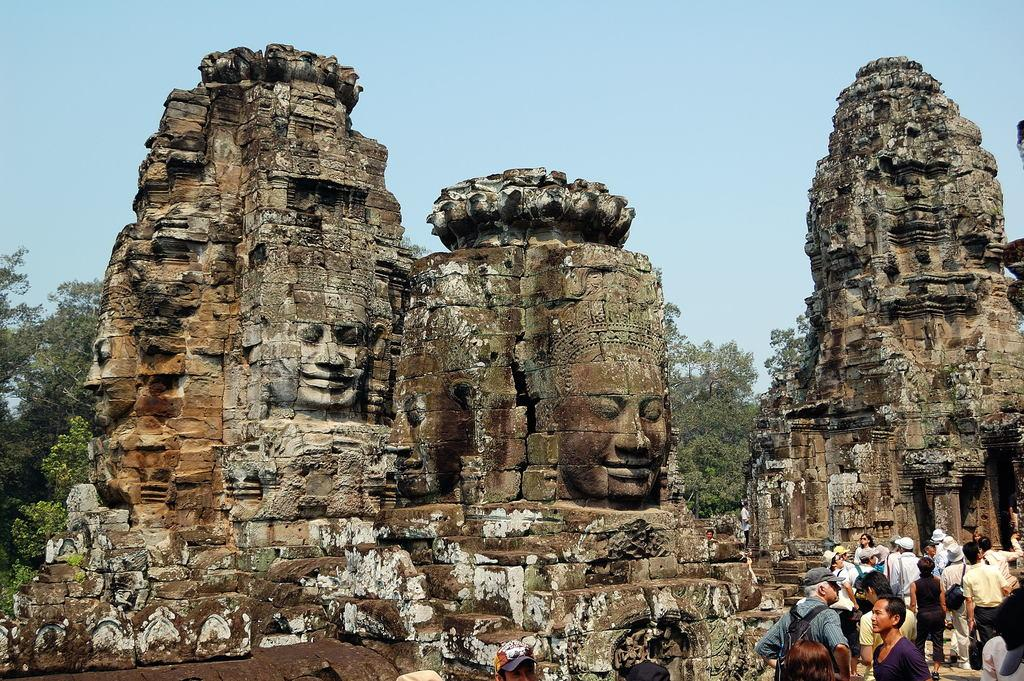How many people are in the group shown in the image? There is a group of people in the image, but the exact number is not specified. What are some people in the group wearing? Some people in the group are wearing caps. What can be seen in the background of the image? There are temples and trees in the background of the image. What type of tank is visible in the image? There is no tank present in the image; it features a group of people and temples in the background. Can you tell me how many cars are parked near the group of people? There is no mention of cars in the image; it only shows a group of people and temples in the background. 